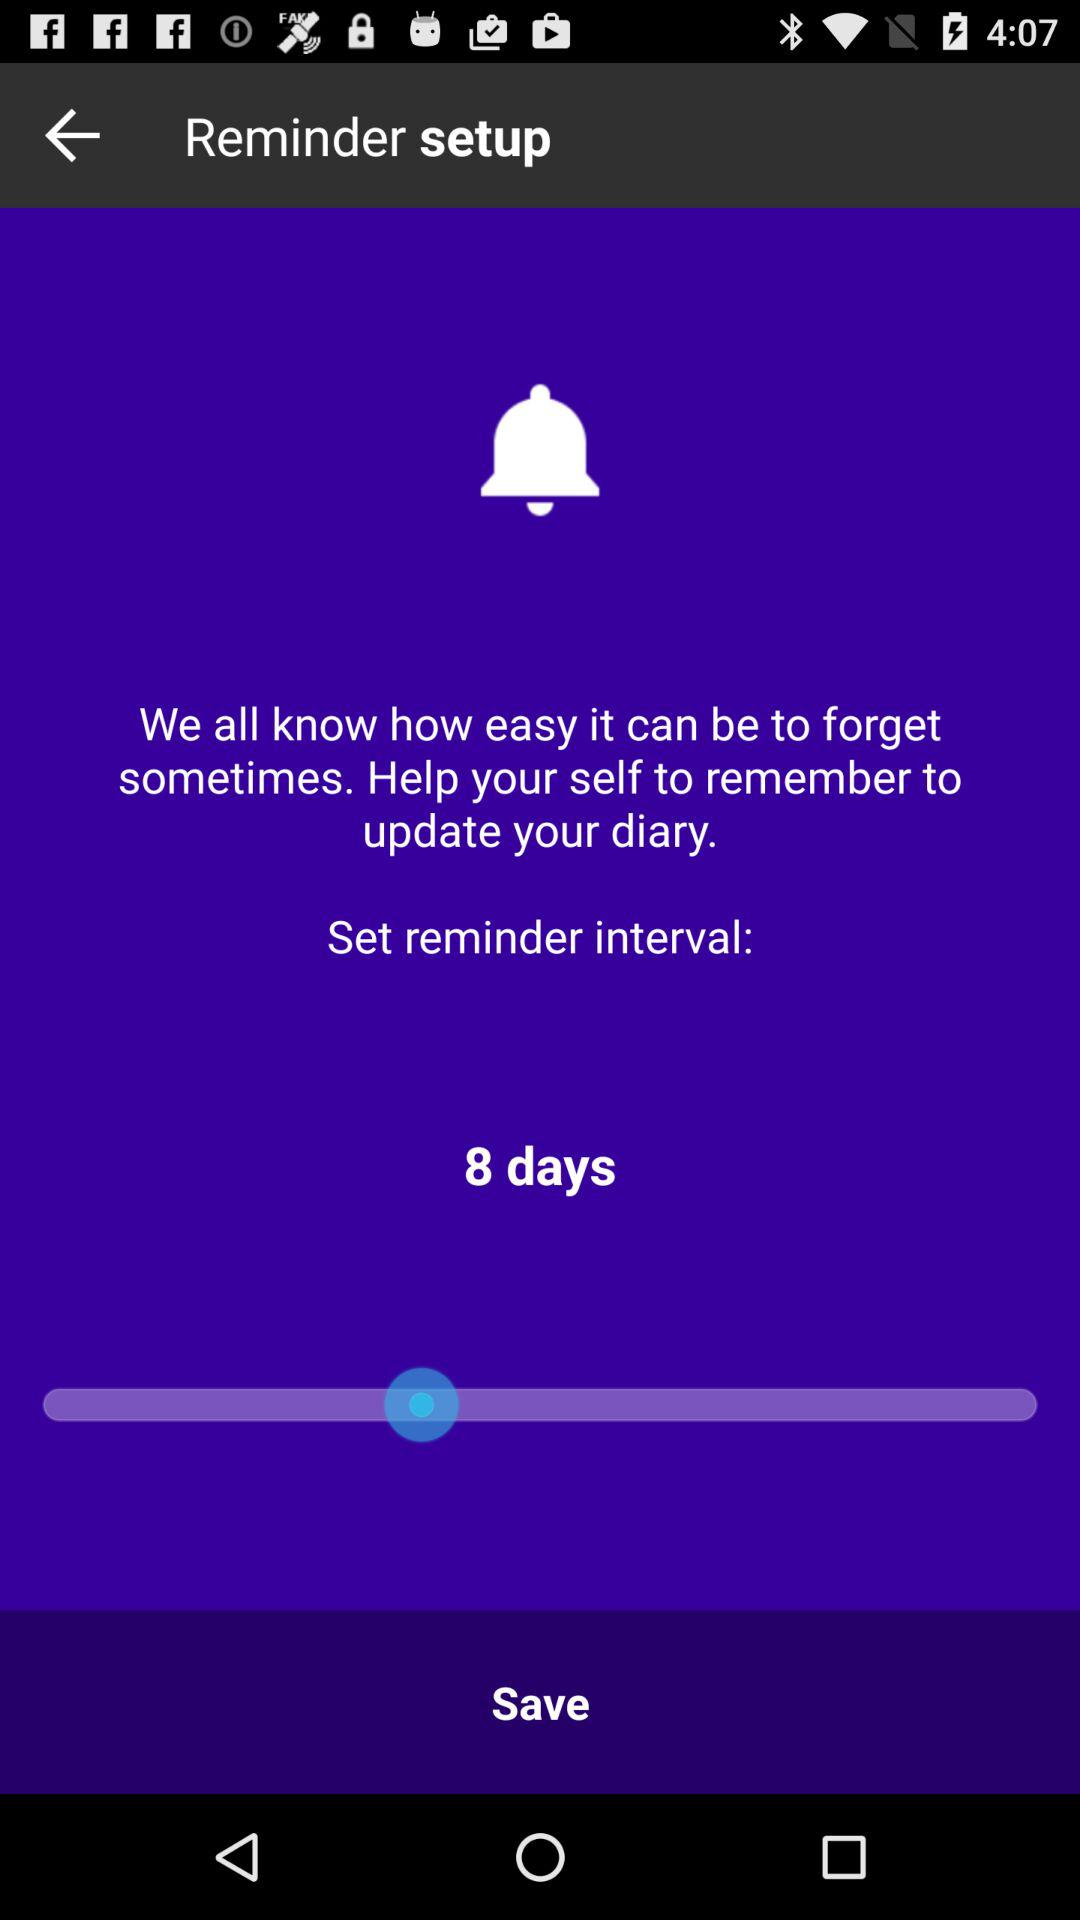What is the set reminder interval? The set reminder interval is 8 days. 